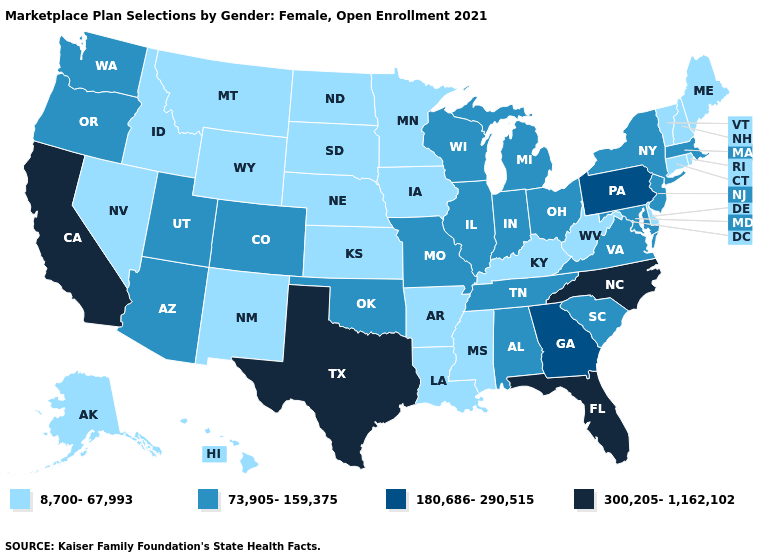What is the value of Louisiana?
Short answer required. 8,700-67,993. What is the lowest value in states that border Iowa?
Concise answer only. 8,700-67,993. Among the states that border South Carolina , which have the highest value?
Answer briefly. North Carolina. Name the states that have a value in the range 300,205-1,162,102?
Keep it brief. California, Florida, North Carolina, Texas. Among the states that border New Hampshire , which have the lowest value?
Keep it brief. Maine, Vermont. What is the value of Idaho?
Write a very short answer. 8,700-67,993. What is the highest value in the West ?
Answer briefly. 300,205-1,162,102. Does California have the highest value in the USA?
Write a very short answer. Yes. Name the states that have a value in the range 73,905-159,375?
Quick response, please. Alabama, Arizona, Colorado, Illinois, Indiana, Maryland, Massachusetts, Michigan, Missouri, New Jersey, New York, Ohio, Oklahoma, Oregon, South Carolina, Tennessee, Utah, Virginia, Washington, Wisconsin. Among the states that border Louisiana , which have the highest value?
Concise answer only. Texas. Name the states that have a value in the range 300,205-1,162,102?
Concise answer only. California, Florida, North Carolina, Texas. Does Pennsylvania have the lowest value in the USA?
Answer briefly. No. What is the highest value in the USA?
Write a very short answer. 300,205-1,162,102. Among the states that border New Mexico , does Texas have the highest value?
Write a very short answer. Yes. Which states have the lowest value in the South?
Be succinct. Arkansas, Delaware, Kentucky, Louisiana, Mississippi, West Virginia. 